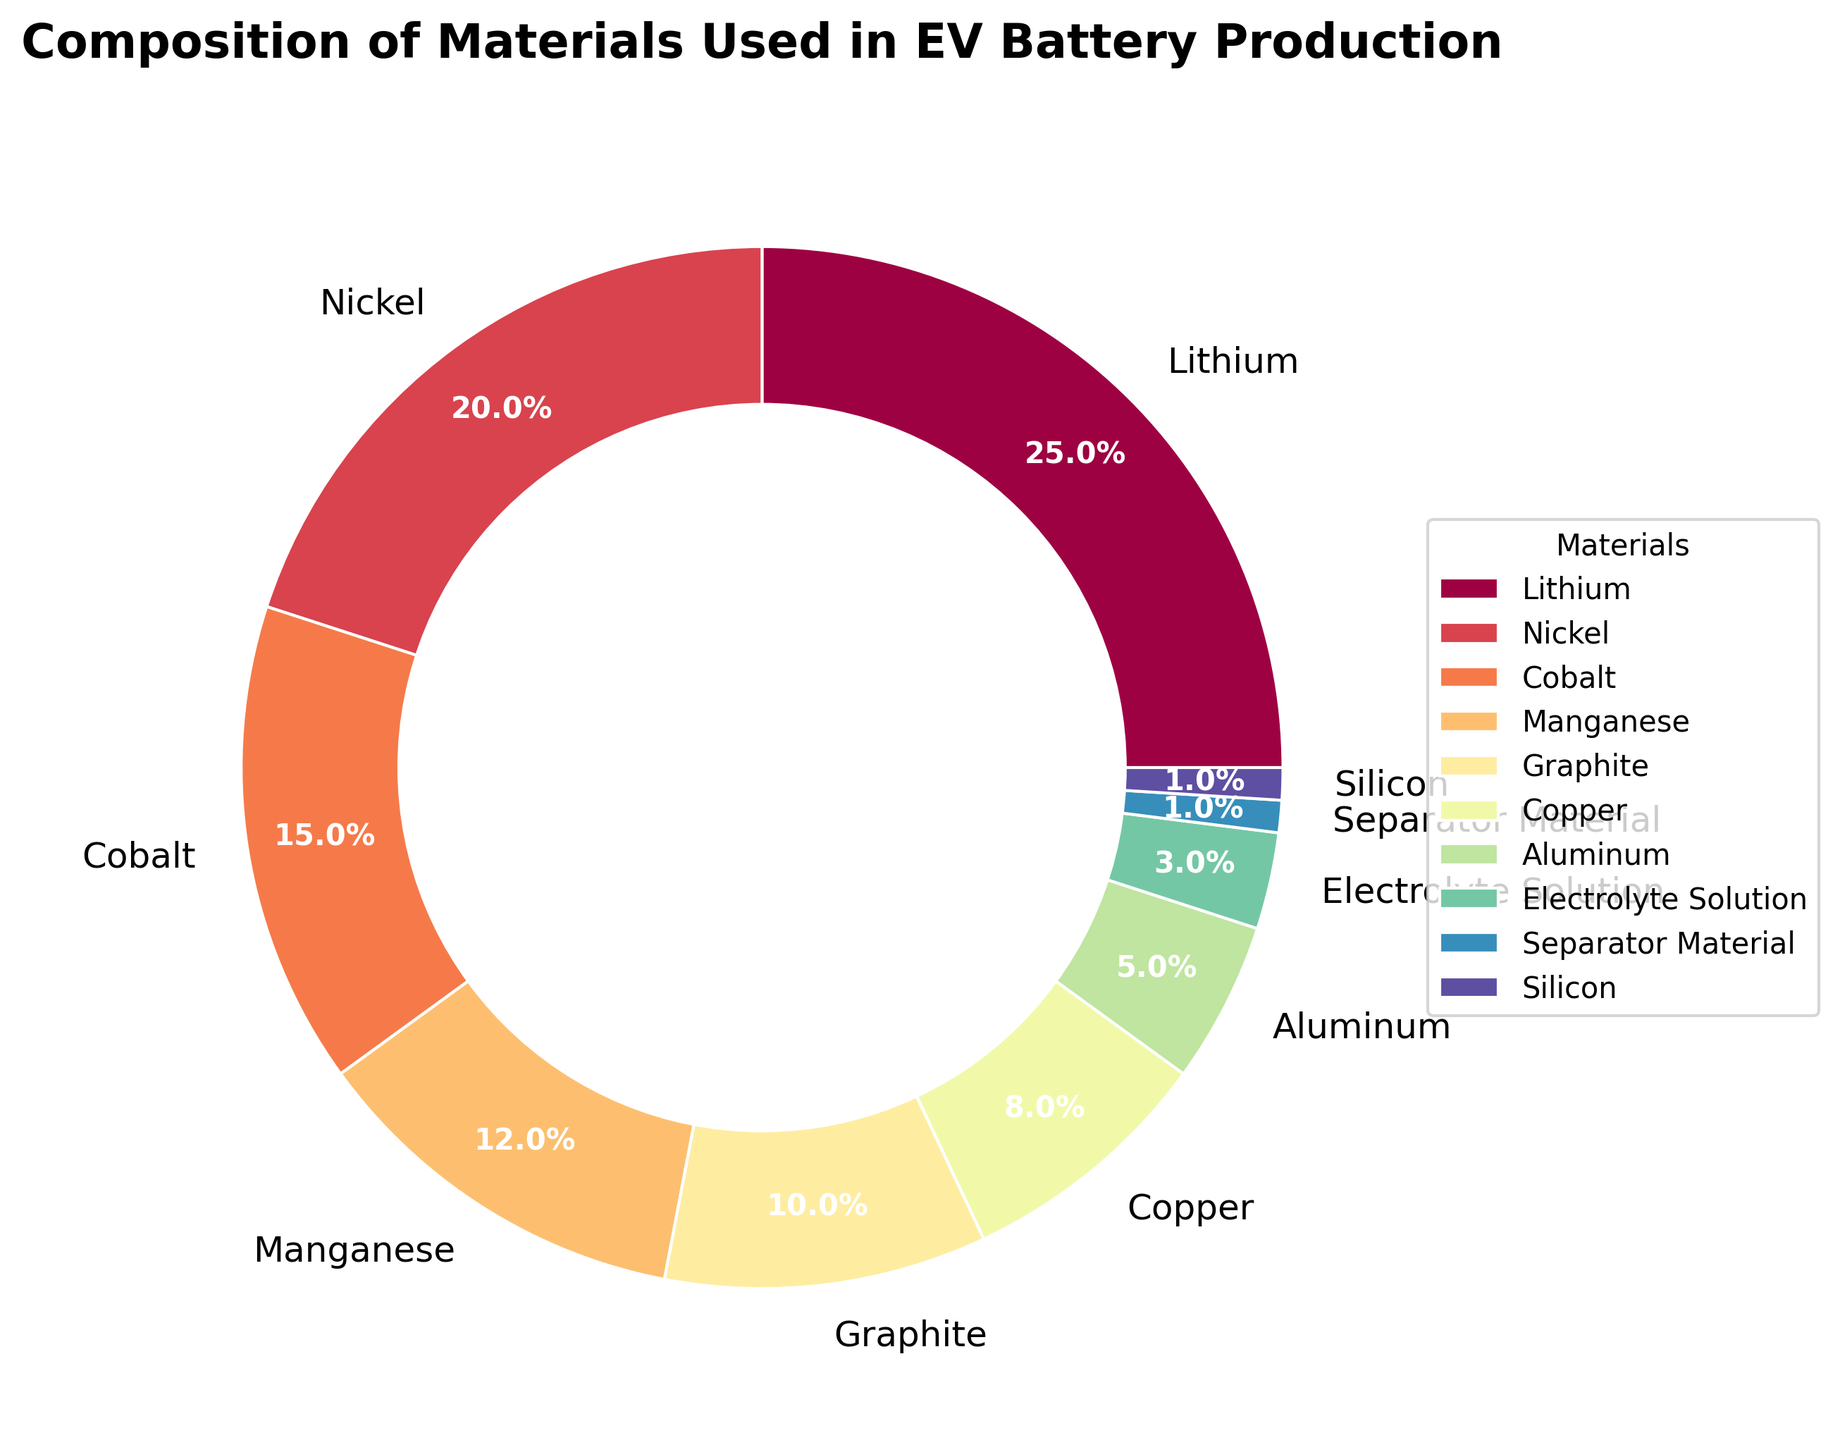Which material has the highest percentage in the composition of EV battery production? The pie chart shows the percentages for each material. The material with the highest percentage is identified by finding the largest section of the pie chart. In this case, it is Lithium.
Answer: Lithium Which two materials combined make up more than 50% of the battery composition? To find the combined percentage of the two materials with the highest percentages, add their individual percentages. Lithium (25%) and Nickel (20%) combined make 45%. Adding Cobalt (15%) brings the total to 60%, which is greater than 50%.
Answer: Lithium and Nickel What is the combined percentage of Nickel, Cobalt, and Manganese? Sum the percentages of Nickel, Cobalt, and Manganese: Nickel (20%) + Cobalt (15%) + Manganese (12%) = 47%.
Answer: 47% What is the difference in percentage between the material with the highest and the material with the lowest composition? Subtract the percentage of the lowest composition material (Separator Material or Silicon, both 1%) from the highest (Lithium, 25%). So, 25% - 1% = 24%.
Answer: 24% How many materials have a percentage above 10%? Count the sections of the pie chart that represent materials with percentages above 10%. Lithium, Nickel, Cobalt, and Manganese meet this criterion.
Answer: 4 What is the percentage contribution of Graphite relative to the total percentage contribution of Graphite and Copper? Calculate the combined percentage of Graphite and Copper: Graphite (10%) + Copper (8%) = 18%. The relative percentage contribution of Graphite is (10% / 18%) * 100% = approximately 55.6%.
Answer: Approx. 55.6% What is the median percentage value among all the materials listed? List the percentages in ascending order: 1, 1, 3, 5, 8, 10, 12, 15, 20, 25. The median is the middle value of this ordered list. Since there are 10 data points, the median is the average of the 5th and 6th values: (8 + 10) / 2 = 9%.
Answer: 9% Which material has twice the percentage of Silicone? Since Silicone has a 1% composition, the material with twice this percentage (2%) is not directly provided in the list. Instead, the closest consideration is the material with a similar but slightly higher percentage, which is Electrolyte Solution with 3% (though slightly more than double). Technically, Electrolyte Solution is the closest.
Answer: Electrolyte Solution What percentage does the Separator Material contribute, and how does its contribution compare to that of Silicon? Both Separator Material and Silicon each contribute 1% to the composition of the EV battery. So, they contribute equally.
Answer: 1%, equally 